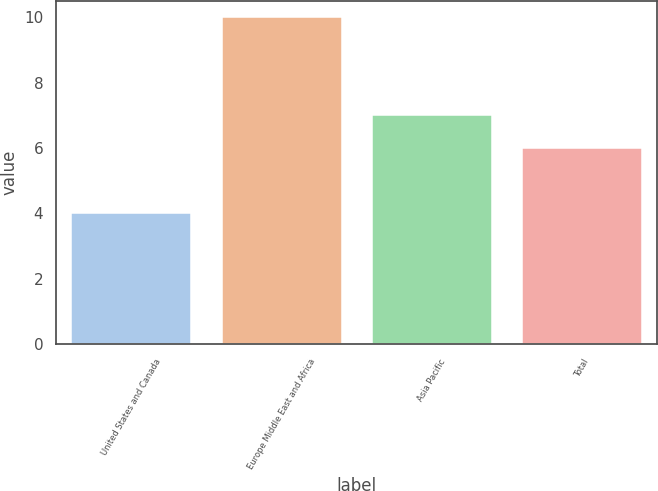<chart> <loc_0><loc_0><loc_500><loc_500><bar_chart><fcel>United States and Canada<fcel>Europe Middle East and Africa<fcel>Asia Pacific<fcel>Total<nl><fcel>4<fcel>10<fcel>7<fcel>6<nl></chart> 